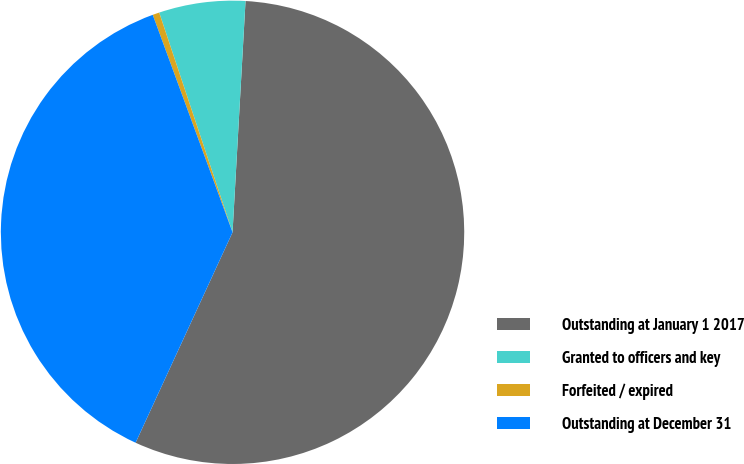Convert chart to OTSL. <chart><loc_0><loc_0><loc_500><loc_500><pie_chart><fcel>Outstanding at January 1 2017<fcel>Granted to officers and key<fcel>Forfeited / expired<fcel>Outstanding at December 31<nl><fcel>55.98%<fcel>6.02%<fcel>0.47%<fcel>37.53%<nl></chart> 